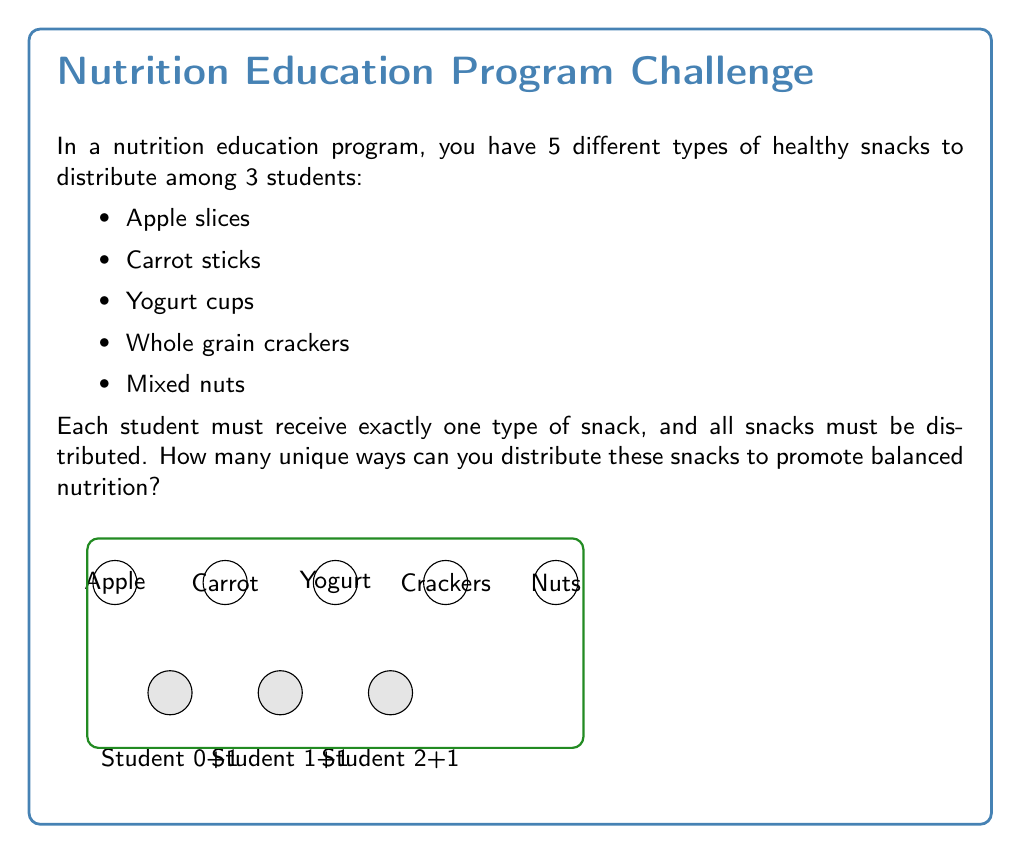Could you help me with this problem? Let's approach this step-by-step using the principles of combinatorics:

1) This problem is an example of permutation with repetition. We are selecting 3 snacks out of 5 types, where the order matters (each student gets a specific snack) and repetition is allowed (we can use the same type of snack more than once).

2) The formula for permutation with repetition is:

   $$n^r$$

   Where $n$ is the number of types to choose from, and $r$ is the number of selections.

3) In this case:
   $n = 5$ (5 types of snacks)
   $r = 3$ (3 students)

4) Plugging these values into our formula:

   $$5^3 = 5 \times 5 \times 5 = 125$$

5) To understand this intuitively:
   - For the first student, we have 5 choices
   - For the second student, we again have 5 choices (as we can repeat snacks)
   - For the third student, we still have 5 choices
   
   So, we multiply: $5 \times 5 \times 5 = 125$

Therefore, there are 125 unique ways to distribute these snacks among the 3 students.
Answer: 125 